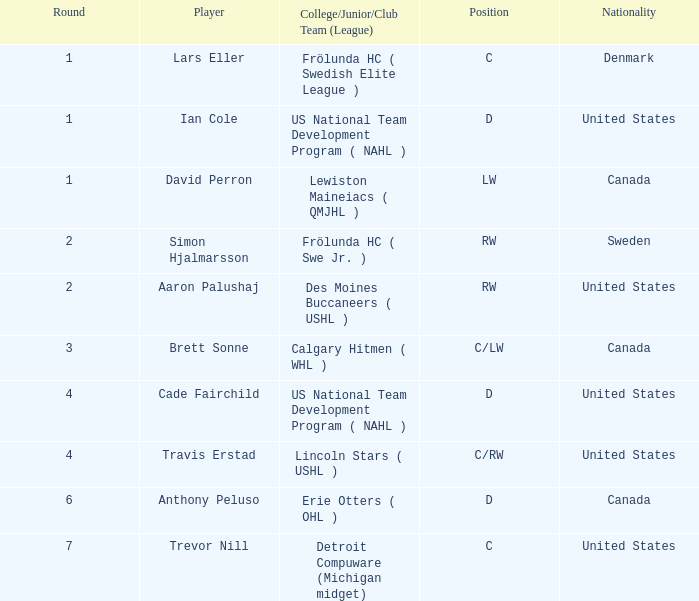What is the highest round of Ian Cole, who played position d from the United States? 1.0. 